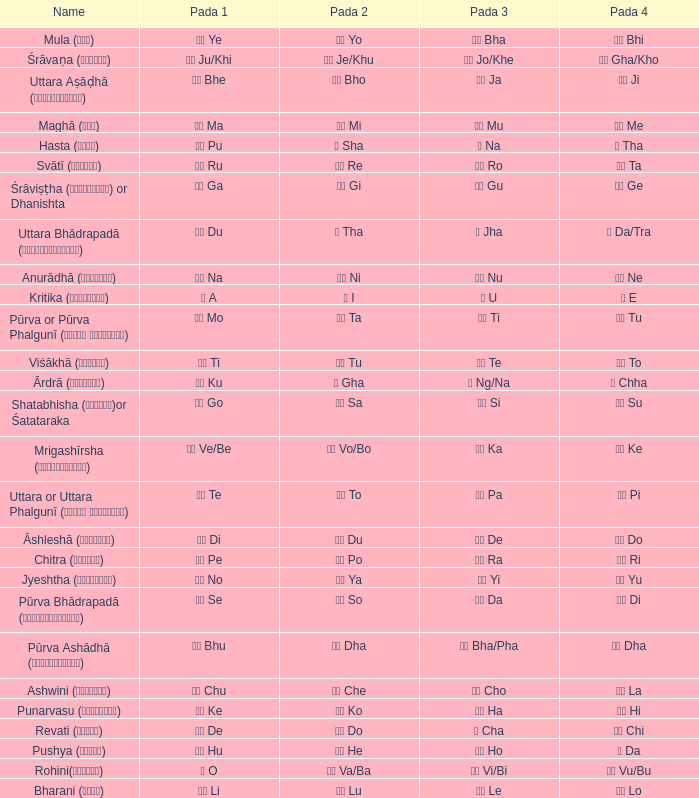What kind of Pada 4 has a Pada 1 of खी ju/khi? खो Gha/Kho. 